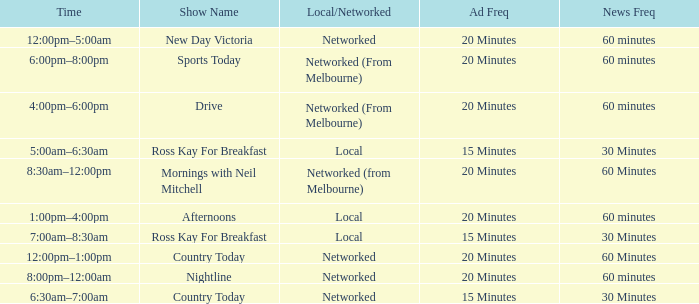What Ad Freq has a News Freq of 60 minutes, and a Local/Networked of local? 20 Minutes. 